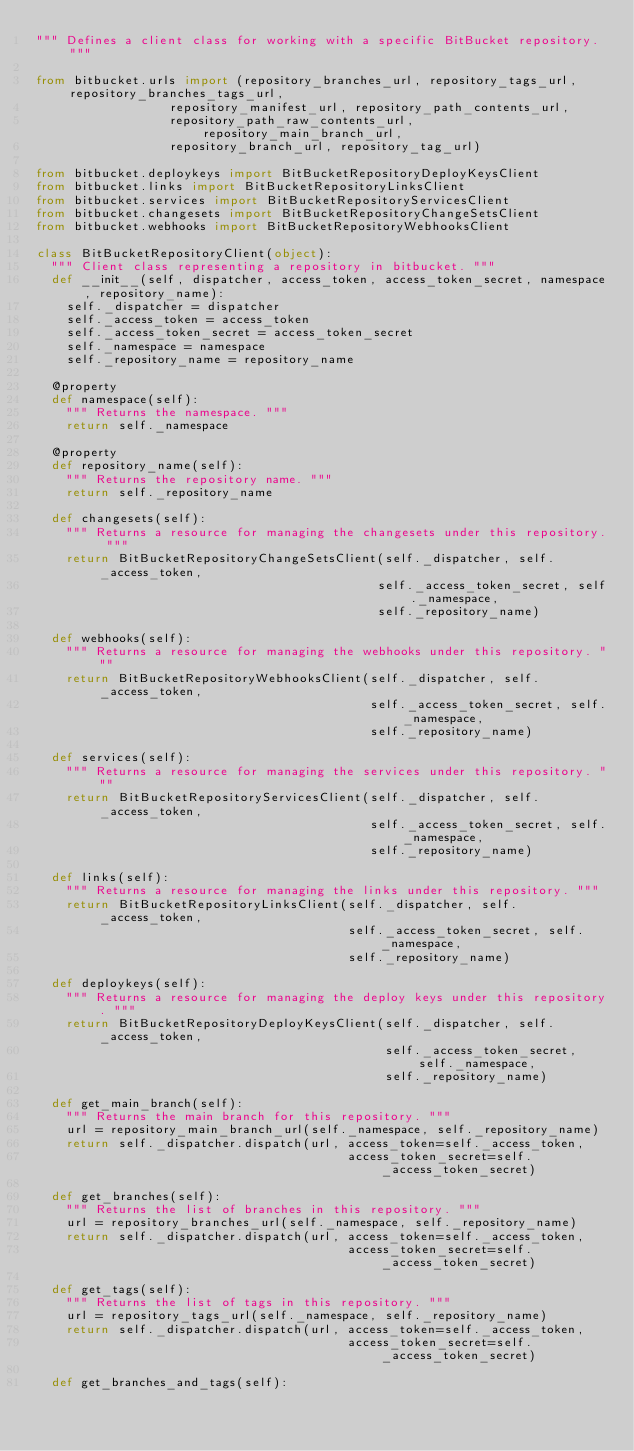<code> <loc_0><loc_0><loc_500><loc_500><_Python_>""" Defines a client class for working with a specific BitBucket repository. """

from bitbucket.urls import (repository_branches_url, repository_tags_url, repository_branches_tags_url,
                  repository_manifest_url, repository_path_contents_url,
                  repository_path_raw_contents_url, repository_main_branch_url,
                  repository_branch_url, repository_tag_url)

from bitbucket.deploykeys import BitBucketRepositoryDeployKeysClient
from bitbucket.links import BitBucketRepositoryLinksClient
from bitbucket.services import BitBucketRepositoryServicesClient
from bitbucket.changesets import BitBucketRepositoryChangeSetsClient
from bitbucket.webhooks import BitBucketRepositoryWebhooksClient

class BitBucketRepositoryClient(object):
  """ Client class representing a repository in bitbucket. """
  def __init__(self, dispatcher, access_token, access_token_secret, namespace, repository_name):
    self._dispatcher = dispatcher
    self._access_token = access_token
    self._access_token_secret = access_token_secret
    self._namespace = namespace
    self._repository_name = repository_name

  @property
  def namespace(self):
    """ Returns the namespace. """
    return self._namespace

  @property
  def repository_name(self):
    """ Returns the repository name. """
    return self._repository_name

  def changesets(self):
    """ Returns a resource for managing the changesets under this repository. """
    return BitBucketRepositoryChangeSetsClient(self._dispatcher, self._access_token,
                                              self._access_token_secret, self._namespace,
                                              self._repository_name)

  def webhooks(self):
    """ Returns a resource for managing the webhooks under this repository. """
    return BitBucketRepositoryWebhooksClient(self._dispatcher, self._access_token,
                                             self._access_token_secret, self._namespace,
                                             self._repository_name)

  def services(self):
    """ Returns a resource for managing the services under this repository. """
    return BitBucketRepositoryServicesClient(self._dispatcher, self._access_token,
                                             self._access_token_secret, self._namespace,
                                             self._repository_name)

  def links(self):
    """ Returns a resource for managing the links under this repository. """
    return BitBucketRepositoryLinksClient(self._dispatcher, self._access_token,
                                          self._access_token_secret, self._namespace,
                                          self._repository_name)

  def deploykeys(self):
    """ Returns a resource for managing the deploy keys under this repository. """
    return BitBucketRepositoryDeployKeysClient(self._dispatcher, self._access_token,
                                               self._access_token_secret, self._namespace,
                                               self._repository_name)

  def get_main_branch(self):
    """ Returns the main branch for this repository. """
    url = repository_main_branch_url(self._namespace, self._repository_name)
    return self._dispatcher.dispatch(url, access_token=self._access_token,
                                          access_token_secret=self._access_token_secret)

  def get_branches(self):
    """ Returns the list of branches in this repository. """
    url = repository_branches_url(self._namespace, self._repository_name)
    return self._dispatcher.dispatch(url, access_token=self._access_token,
                                          access_token_secret=self._access_token_secret)

  def get_tags(self):
    """ Returns the list of tags in this repository. """
    url = repository_tags_url(self._namespace, self._repository_name)
    return self._dispatcher.dispatch(url, access_token=self._access_token,
                                          access_token_secret=self._access_token_secret)

  def get_branches_and_tags(self):</code> 